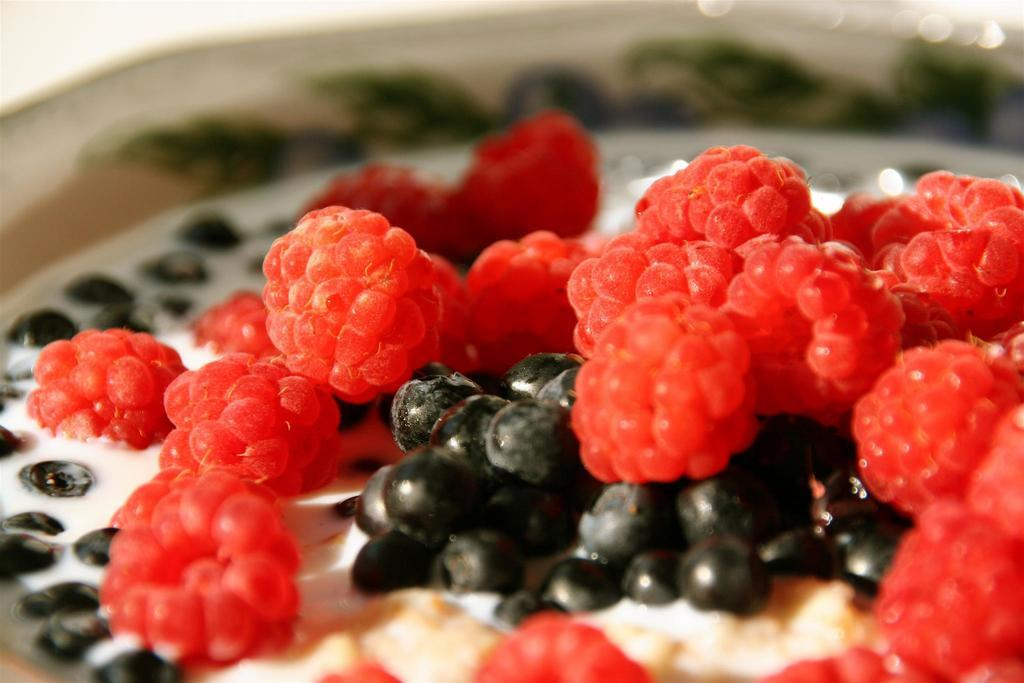What colors are the fruits in the image? The fruits in the image are red and black in color. What is the liquid surrounding the fruits? The fruits are in a white color liquid. Can you describe the background of the image? The background of the image is blurred. What type of wealth can be seen in the image? There is no wealth present in the image; it features fruits in a white color liquid with a blurred background. 